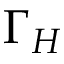Convert formula to latex. <formula><loc_0><loc_0><loc_500><loc_500>\Gamma _ { H }</formula> 